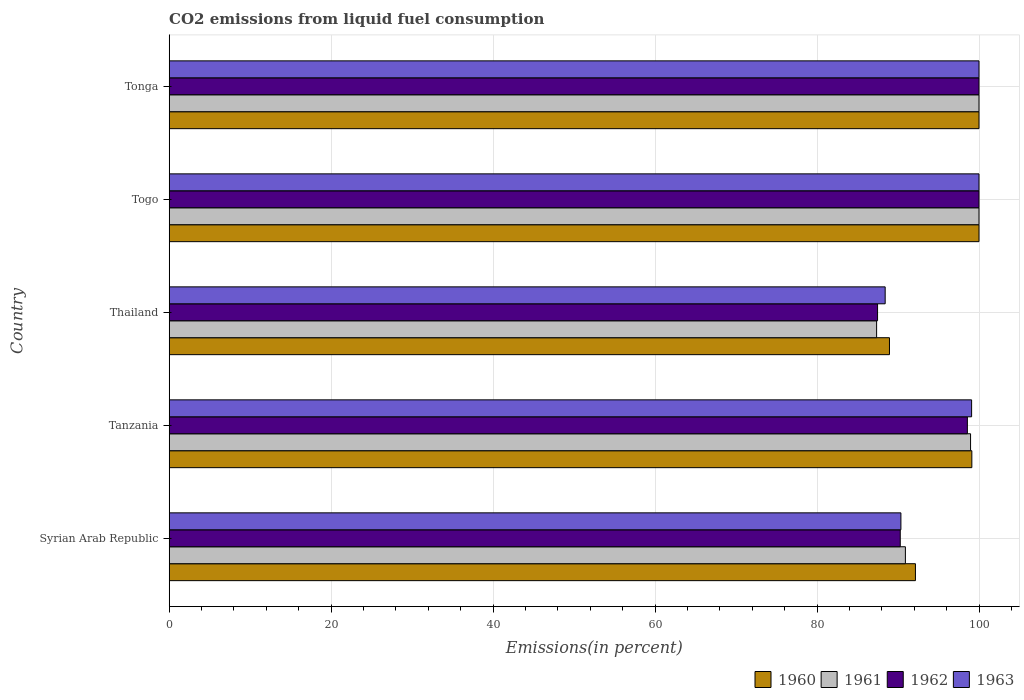What is the label of the 3rd group of bars from the top?
Provide a succinct answer. Thailand. What is the total CO2 emitted in 1963 in Syrian Arab Republic?
Keep it short and to the point. 90.36. Across all countries, what is the minimum total CO2 emitted in 1962?
Make the answer very short. 87.47. In which country was the total CO2 emitted in 1960 maximum?
Your response must be concise. Togo. In which country was the total CO2 emitted in 1962 minimum?
Give a very brief answer. Thailand. What is the total total CO2 emitted in 1963 in the graph?
Your answer should be very brief. 477.86. What is the difference between the total CO2 emitted in 1960 in Thailand and that in Tonga?
Make the answer very short. -11.06. What is the difference between the total CO2 emitted in 1960 in Tanzania and the total CO2 emitted in 1961 in Tonga?
Provide a short and direct response. -0.88. What is the average total CO2 emitted in 1960 per country?
Your answer should be compact. 96.04. What is the difference between the total CO2 emitted in 1961 and total CO2 emitted in 1963 in Togo?
Offer a very short reply. 0. In how many countries, is the total CO2 emitted in 1960 greater than 60 %?
Ensure brevity in your answer.  5. What is the ratio of the total CO2 emitted in 1963 in Syrian Arab Republic to that in Togo?
Provide a succinct answer. 0.9. What is the difference between the highest and the lowest total CO2 emitted in 1961?
Make the answer very short. 12.64. Is the sum of the total CO2 emitted in 1961 in Thailand and Togo greater than the maximum total CO2 emitted in 1962 across all countries?
Your answer should be very brief. Yes. Is it the case that in every country, the sum of the total CO2 emitted in 1961 and total CO2 emitted in 1963 is greater than the sum of total CO2 emitted in 1960 and total CO2 emitted in 1962?
Make the answer very short. No. What does the 3rd bar from the bottom in Tanzania represents?
Give a very brief answer. 1962. Is it the case that in every country, the sum of the total CO2 emitted in 1963 and total CO2 emitted in 1961 is greater than the total CO2 emitted in 1962?
Ensure brevity in your answer.  Yes. How many countries are there in the graph?
Ensure brevity in your answer.  5. What is the difference between two consecutive major ticks on the X-axis?
Provide a short and direct response. 20. Does the graph contain grids?
Keep it short and to the point. Yes. How many legend labels are there?
Your answer should be very brief. 4. How are the legend labels stacked?
Make the answer very short. Horizontal. What is the title of the graph?
Your answer should be compact. CO2 emissions from liquid fuel consumption. What is the label or title of the X-axis?
Your response must be concise. Emissions(in percent). What is the Emissions(in percent) in 1960 in Syrian Arab Republic?
Provide a succinct answer. 92.15. What is the Emissions(in percent) of 1961 in Syrian Arab Republic?
Your answer should be compact. 90.91. What is the Emissions(in percent) of 1962 in Syrian Arab Republic?
Keep it short and to the point. 90.27. What is the Emissions(in percent) in 1963 in Syrian Arab Republic?
Your answer should be very brief. 90.36. What is the Emissions(in percent) in 1960 in Tanzania?
Provide a short and direct response. 99.12. What is the Emissions(in percent) of 1961 in Tanzania?
Your answer should be compact. 98.96. What is the Emissions(in percent) in 1962 in Tanzania?
Your answer should be very brief. 98.56. What is the Emissions(in percent) of 1963 in Tanzania?
Provide a succinct answer. 99.09. What is the Emissions(in percent) of 1960 in Thailand?
Your answer should be compact. 88.94. What is the Emissions(in percent) in 1961 in Thailand?
Ensure brevity in your answer.  87.36. What is the Emissions(in percent) in 1962 in Thailand?
Give a very brief answer. 87.47. What is the Emissions(in percent) of 1963 in Thailand?
Your answer should be very brief. 88.41. What is the Emissions(in percent) in 1960 in Togo?
Your response must be concise. 100. What is the Emissions(in percent) in 1961 in Togo?
Your answer should be very brief. 100. What is the Emissions(in percent) in 1962 in Togo?
Your answer should be compact. 100. What is the Emissions(in percent) of 1962 in Tonga?
Offer a terse response. 100. What is the Emissions(in percent) in 1963 in Tonga?
Give a very brief answer. 100. Across all countries, what is the maximum Emissions(in percent) in 1961?
Offer a very short reply. 100. Across all countries, what is the minimum Emissions(in percent) in 1960?
Provide a short and direct response. 88.94. Across all countries, what is the minimum Emissions(in percent) of 1961?
Give a very brief answer. 87.36. Across all countries, what is the minimum Emissions(in percent) of 1962?
Make the answer very short. 87.47. Across all countries, what is the minimum Emissions(in percent) of 1963?
Provide a short and direct response. 88.41. What is the total Emissions(in percent) of 1960 in the graph?
Your response must be concise. 480.21. What is the total Emissions(in percent) of 1961 in the graph?
Offer a very short reply. 477.22. What is the total Emissions(in percent) in 1962 in the graph?
Offer a very short reply. 476.31. What is the total Emissions(in percent) of 1963 in the graph?
Offer a terse response. 477.86. What is the difference between the Emissions(in percent) of 1960 in Syrian Arab Republic and that in Tanzania?
Make the answer very short. -6.96. What is the difference between the Emissions(in percent) of 1961 in Syrian Arab Republic and that in Tanzania?
Your answer should be compact. -8.05. What is the difference between the Emissions(in percent) in 1962 in Syrian Arab Republic and that in Tanzania?
Provide a short and direct response. -8.29. What is the difference between the Emissions(in percent) in 1963 in Syrian Arab Republic and that in Tanzania?
Keep it short and to the point. -8.73. What is the difference between the Emissions(in percent) in 1960 in Syrian Arab Republic and that in Thailand?
Keep it short and to the point. 3.21. What is the difference between the Emissions(in percent) in 1961 in Syrian Arab Republic and that in Thailand?
Give a very brief answer. 3.55. What is the difference between the Emissions(in percent) in 1962 in Syrian Arab Republic and that in Thailand?
Offer a terse response. 2.8. What is the difference between the Emissions(in percent) of 1963 in Syrian Arab Republic and that in Thailand?
Your answer should be compact. 1.94. What is the difference between the Emissions(in percent) of 1960 in Syrian Arab Republic and that in Togo?
Keep it short and to the point. -7.85. What is the difference between the Emissions(in percent) in 1961 in Syrian Arab Republic and that in Togo?
Your answer should be compact. -9.09. What is the difference between the Emissions(in percent) in 1962 in Syrian Arab Republic and that in Togo?
Your answer should be very brief. -9.73. What is the difference between the Emissions(in percent) of 1963 in Syrian Arab Republic and that in Togo?
Provide a succinct answer. -9.64. What is the difference between the Emissions(in percent) of 1960 in Syrian Arab Republic and that in Tonga?
Keep it short and to the point. -7.85. What is the difference between the Emissions(in percent) in 1961 in Syrian Arab Republic and that in Tonga?
Your answer should be very brief. -9.09. What is the difference between the Emissions(in percent) of 1962 in Syrian Arab Republic and that in Tonga?
Your answer should be very brief. -9.73. What is the difference between the Emissions(in percent) of 1963 in Syrian Arab Republic and that in Tonga?
Your answer should be compact. -9.64. What is the difference between the Emissions(in percent) in 1960 in Tanzania and that in Thailand?
Offer a very short reply. 10.17. What is the difference between the Emissions(in percent) in 1961 in Tanzania and that in Thailand?
Give a very brief answer. 11.6. What is the difference between the Emissions(in percent) of 1962 in Tanzania and that in Thailand?
Provide a short and direct response. 11.09. What is the difference between the Emissions(in percent) in 1963 in Tanzania and that in Thailand?
Offer a terse response. 10.67. What is the difference between the Emissions(in percent) in 1960 in Tanzania and that in Togo?
Ensure brevity in your answer.  -0.89. What is the difference between the Emissions(in percent) in 1961 in Tanzania and that in Togo?
Provide a short and direct response. -1.04. What is the difference between the Emissions(in percent) in 1962 in Tanzania and that in Togo?
Provide a short and direct response. -1.44. What is the difference between the Emissions(in percent) in 1963 in Tanzania and that in Togo?
Offer a very short reply. -0.91. What is the difference between the Emissions(in percent) in 1960 in Tanzania and that in Tonga?
Give a very brief answer. -0.89. What is the difference between the Emissions(in percent) of 1961 in Tanzania and that in Tonga?
Your answer should be very brief. -1.04. What is the difference between the Emissions(in percent) of 1962 in Tanzania and that in Tonga?
Offer a terse response. -1.44. What is the difference between the Emissions(in percent) of 1963 in Tanzania and that in Tonga?
Provide a succinct answer. -0.91. What is the difference between the Emissions(in percent) of 1960 in Thailand and that in Togo?
Offer a terse response. -11.06. What is the difference between the Emissions(in percent) in 1961 in Thailand and that in Togo?
Give a very brief answer. -12.64. What is the difference between the Emissions(in percent) in 1962 in Thailand and that in Togo?
Provide a short and direct response. -12.53. What is the difference between the Emissions(in percent) of 1963 in Thailand and that in Togo?
Your response must be concise. -11.59. What is the difference between the Emissions(in percent) of 1960 in Thailand and that in Tonga?
Offer a terse response. -11.06. What is the difference between the Emissions(in percent) in 1961 in Thailand and that in Tonga?
Give a very brief answer. -12.64. What is the difference between the Emissions(in percent) of 1962 in Thailand and that in Tonga?
Give a very brief answer. -12.53. What is the difference between the Emissions(in percent) in 1963 in Thailand and that in Tonga?
Ensure brevity in your answer.  -11.59. What is the difference between the Emissions(in percent) of 1960 in Togo and that in Tonga?
Keep it short and to the point. 0. What is the difference between the Emissions(in percent) of 1961 in Togo and that in Tonga?
Offer a very short reply. 0. What is the difference between the Emissions(in percent) in 1963 in Togo and that in Tonga?
Your answer should be very brief. 0. What is the difference between the Emissions(in percent) in 1960 in Syrian Arab Republic and the Emissions(in percent) in 1961 in Tanzania?
Offer a very short reply. -6.81. What is the difference between the Emissions(in percent) in 1960 in Syrian Arab Republic and the Emissions(in percent) in 1962 in Tanzania?
Provide a succinct answer. -6.41. What is the difference between the Emissions(in percent) in 1960 in Syrian Arab Republic and the Emissions(in percent) in 1963 in Tanzania?
Offer a very short reply. -6.94. What is the difference between the Emissions(in percent) in 1961 in Syrian Arab Republic and the Emissions(in percent) in 1962 in Tanzania?
Offer a very short reply. -7.66. What is the difference between the Emissions(in percent) in 1961 in Syrian Arab Republic and the Emissions(in percent) in 1963 in Tanzania?
Make the answer very short. -8.18. What is the difference between the Emissions(in percent) in 1962 in Syrian Arab Republic and the Emissions(in percent) in 1963 in Tanzania?
Your answer should be compact. -8.81. What is the difference between the Emissions(in percent) of 1960 in Syrian Arab Republic and the Emissions(in percent) of 1961 in Thailand?
Your answer should be very brief. 4.79. What is the difference between the Emissions(in percent) of 1960 in Syrian Arab Republic and the Emissions(in percent) of 1962 in Thailand?
Ensure brevity in your answer.  4.68. What is the difference between the Emissions(in percent) of 1960 in Syrian Arab Republic and the Emissions(in percent) of 1963 in Thailand?
Give a very brief answer. 3.74. What is the difference between the Emissions(in percent) of 1961 in Syrian Arab Republic and the Emissions(in percent) of 1962 in Thailand?
Provide a succinct answer. 3.44. What is the difference between the Emissions(in percent) in 1961 in Syrian Arab Republic and the Emissions(in percent) in 1963 in Thailand?
Your answer should be compact. 2.5. What is the difference between the Emissions(in percent) of 1962 in Syrian Arab Republic and the Emissions(in percent) of 1963 in Thailand?
Offer a terse response. 1.86. What is the difference between the Emissions(in percent) in 1960 in Syrian Arab Republic and the Emissions(in percent) in 1961 in Togo?
Your answer should be compact. -7.85. What is the difference between the Emissions(in percent) in 1960 in Syrian Arab Republic and the Emissions(in percent) in 1962 in Togo?
Ensure brevity in your answer.  -7.85. What is the difference between the Emissions(in percent) in 1960 in Syrian Arab Republic and the Emissions(in percent) in 1963 in Togo?
Your response must be concise. -7.85. What is the difference between the Emissions(in percent) of 1961 in Syrian Arab Republic and the Emissions(in percent) of 1962 in Togo?
Provide a short and direct response. -9.09. What is the difference between the Emissions(in percent) of 1961 in Syrian Arab Republic and the Emissions(in percent) of 1963 in Togo?
Your answer should be very brief. -9.09. What is the difference between the Emissions(in percent) in 1962 in Syrian Arab Republic and the Emissions(in percent) in 1963 in Togo?
Your answer should be very brief. -9.73. What is the difference between the Emissions(in percent) of 1960 in Syrian Arab Republic and the Emissions(in percent) of 1961 in Tonga?
Your answer should be compact. -7.85. What is the difference between the Emissions(in percent) of 1960 in Syrian Arab Republic and the Emissions(in percent) of 1962 in Tonga?
Your answer should be very brief. -7.85. What is the difference between the Emissions(in percent) in 1960 in Syrian Arab Republic and the Emissions(in percent) in 1963 in Tonga?
Your response must be concise. -7.85. What is the difference between the Emissions(in percent) in 1961 in Syrian Arab Republic and the Emissions(in percent) in 1962 in Tonga?
Provide a short and direct response. -9.09. What is the difference between the Emissions(in percent) in 1961 in Syrian Arab Republic and the Emissions(in percent) in 1963 in Tonga?
Provide a short and direct response. -9.09. What is the difference between the Emissions(in percent) in 1962 in Syrian Arab Republic and the Emissions(in percent) in 1963 in Tonga?
Your answer should be compact. -9.73. What is the difference between the Emissions(in percent) in 1960 in Tanzania and the Emissions(in percent) in 1961 in Thailand?
Ensure brevity in your answer.  11.76. What is the difference between the Emissions(in percent) of 1960 in Tanzania and the Emissions(in percent) of 1962 in Thailand?
Your response must be concise. 11.64. What is the difference between the Emissions(in percent) in 1960 in Tanzania and the Emissions(in percent) in 1963 in Thailand?
Keep it short and to the point. 10.7. What is the difference between the Emissions(in percent) of 1961 in Tanzania and the Emissions(in percent) of 1962 in Thailand?
Keep it short and to the point. 11.49. What is the difference between the Emissions(in percent) of 1961 in Tanzania and the Emissions(in percent) of 1963 in Thailand?
Give a very brief answer. 10.54. What is the difference between the Emissions(in percent) in 1962 in Tanzania and the Emissions(in percent) in 1963 in Thailand?
Your answer should be compact. 10.15. What is the difference between the Emissions(in percent) of 1960 in Tanzania and the Emissions(in percent) of 1961 in Togo?
Provide a short and direct response. -0.89. What is the difference between the Emissions(in percent) of 1960 in Tanzania and the Emissions(in percent) of 1962 in Togo?
Give a very brief answer. -0.89. What is the difference between the Emissions(in percent) in 1960 in Tanzania and the Emissions(in percent) in 1963 in Togo?
Your answer should be compact. -0.89. What is the difference between the Emissions(in percent) in 1961 in Tanzania and the Emissions(in percent) in 1962 in Togo?
Offer a very short reply. -1.04. What is the difference between the Emissions(in percent) in 1961 in Tanzania and the Emissions(in percent) in 1963 in Togo?
Offer a terse response. -1.04. What is the difference between the Emissions(in percent) of 1962 in Tanzania and the Emissions(in percent) of 1963 in Togo?
Make the answer very short. -1.44. What is the difference between the Emissions(in percent) in 1960 in Tanzania and the Emissions(in percent) in 1961 in Tonga?
Ensure brevity in your answer.  -0.89. What is the difference between the Emissions(in percent) of 1960 in Tanzania and the Emissions(in percent) of 1962 in Tonga?
Offer a very short reply. -0.89. What is the difference between the Emissions(in percent) in 1960 in Tanzania and the Emissions(in percent) in 1963 in Tonga?
Provide a short and direct response. -0.89. What is the difference between the Emissions(in percent) in 1961 in Tanzania and the Emissions(in percent) in 1962 in Tonga?
Ensure brevity in your answer.  -1.04. What is the difference between the Emissions(in percent) of 1961 in Tanzania and the Emissions(in percent) of 1963 in Tonga?
Offer a very short reply. -1.04. What is the difference between the Emissions(in percent) in 1962 in Tanzania and the Emissions(in percent) in 1963 in Tonga?
Offer a very short reply. -1.44. What is the difference between the Emissions(in percent) of 1960 in Thailand and the Emissions(in percent) of 1961 in Togo?
Keep it short and to the point. -11.06. What is the difference between the Emissions(in percent) of 1960 in Thailand and the Emissions(in percent) of 1962 in Togo?
Offer a very short reply. -11.06. What is the difference between the Emissions(in percent) of 1960 in Thailand and the Emissions(in percent) of 1963 in Togo?
Your answer should be compact. -11.06. What is the difference between the Emissions(in percent) of 1961 in Thailand and the Emissions(in percent) of 1962 in Togo?
Keep it short and to the point. -12.64. What is the difference between the Emissions(in percent) of 1961 in Thailand and the Emissions(in percent) of 1963 in Togo?
Make the answer very short. -12.64. What is the difference between the Emissions(in percent) of 1962 in Thailand and the Emissions(in percent) of 1963 in Togo?
Keep it short and to the point. -12.53. What is the difference between the Emissions(in percent) in 1960 in Thailand and the Emissions(in percent) in 1961 in Tonga?
Ensure brevity in your answer.  -11.06. What is the difference between the Emissions(in percent) of 1960 in Thailand and the Emissions(in percent) of 1962 in Tonga?
Keep it short and to the point. -11.06. What is the difference between the Emissions(in percent) of 1960 in Thailand and the Emissions(in percent) of 1963 in Tonga?
Give a very brief answer. -11.06. What is the difference between the Emissions(in percent) of 1961 in Thailand and the Emissions(in percent) of 1962 in Tonga?
Make the answer very short. -12.64. What is the difference between the Emissions(in percent) in 1961 in Thailand and the Emissions(in percent) in 1963 in Tonga?
Offer a very short reply. -12.64. What is the difference between the Emissions(in percent) of 1962 in Thailand and the Emissions(in percent) of 1963 in Tonga?
Your response must be concise. -12.53. What is the average Emissions(in percent) of 1960 per country?
Offer a very short reply. 96.04. What is the average Emissions(in percent) in 1961 per country?
Ensure brevity in your answer.  95.44. What is the average Emissions(in percent) in 1962 per country?
Your answer should be compact. 95.26. What is the average Emissions(in percent) of 1963 per country?
Your response must be concise. 95.57. What is the difference between the Emissions(in percent) in 1960 and Emissions(in percent) in 1961 in Syrian Arab Republic?
Offer a very short reply. 1.24. What is the difference between the Emissions(in percent) in 1960 and Emissions(in percent) in 1962 in Syrian Arab Republic?
Ensure brevity in your answer.  1.88. What is the difference between the Emissions(in percent) in 1960 and Emissions(in percent) in 1963 in Syrian Arab Republic?
Offer a terse response. 1.79. What is the difference between the Emissions(in percent) of 1961 and Emissions(in percent) of 1962 in Syrian Arab Republic?
Offer a terse response. 0.63. What is the difference between the Emissions(in percent) of 1961 and Emissions(in percent) of 1963 in Syrian Arab Republic?
Provide a succinct answer. 0.55. What is the difference between the Emissions(in percent) in 1962 and Emissions(in percent) in 1963 in Syrian Arab Republic?
Offer a very short reply. -0.08. What is the difference between the Emissions(in percent) of 1960 and Emissions(in percent) of 1961 in Tanzania?
Offer a very short reply. 0.16. What is the difference between the Emissions(in percent) of 1960 and Emissions(in percent) of 1962 in Tanzania?
Offer a terse response. 0.55. What is the difference between the Emissions(in percent) in 1960 and Emissions(in percent) in 1963 in Tanzania?
Your answer should be compact. 0.03. What is the difference between the Emissions(in percent) of 1961 and Emissions(in percent) of 1962 in Tanzania?
Offer a very short reply. 0.39. What is the difference between the Emissions(in percent) of 1961 and Emissions(in percent) of 1963 in Tanzania?
Offer a very short reply. -0.13. What is the difference between the Emissions(in percent) in 1962 and Emissions(in percent) in 1963 in Tanzania?
Give a very brief answer. -0.52. What is the difference between the Emissions(in percent) of 1960 and Emissions(in percent) of 1961 in Thailand?
Offer a terse response. 1.59. What is the difference between the Emissions(in percent) of 1960 and Emissions(in percent) of 1962 in Thailand?
Your answer should be compact. 1.47. What is the difference between the Emissions(in percent) in 1960 and Emissions(in percent) in 1963 in Thailand?
Give a very brief answer. 0.53. What is the difference between the Emissions(in percent) in 1961 and Emissions(in percent) in 1962 in Thailand?
Give a very brief answer. -0.12. What is the difference between the Emissions(in percent) in 1961 and Emissions(in percent) in 1963 in Thailand?
Keep it short and to the point. -1.06. What is the difference between the Emissions(in percent) of 1962 and Emissions(in percent) of 1963 in Thailand?
Keep it short and to the point. -0.94. What is the difference between the Emissions(in percent) of 1960 and Emissions(in percent) of 1961 in Togo?
Make the answer very short. 0. What is the difference between the Emissions(in percent) in 1960 and Emissions(in percent) in 1963 in Togo?
Your response must be concise. 0. What is the difference between the Emissions(in percent) of 1961 and Emissions(in percent) of 1962 in Togo?
Offer a terse response. 0. What is the difference between the Emissions(in percent) of 1960 and Emissions(in percent) of 1962 in Tonga?
Offer a very short reply. 0. What is the difference between the Emissions(in percent) of 1961 and Emissions(in percent) of 1962 in Tonga?
Your answer should be very brief. 0. What is the difference between the Emissions(in percent) of 1962 and Emissions(in percent) of 1963 in Tonga?
Keep it short and to the point. 0. What is the ratio of the Emissions(in percent) in 1960 in Syrian Arab Republic to that in Tanzania?
Your response must be concise. 0.93. What is the ratio of the Emissions(in percent) in 1961 in Syrian Arab Republic to that in Tanzania?
Your answer should be very brief. 0.92. What is the ratio of the Emissions(in percent) in 1962 in Syrian Arab Republic to that in Tanzania?
Provide a short and direct response. 0.92. What is the ratio of the Emissions(in percent) of 1963 in Syrian Arab Republic to that in Tanzania?
Provide a succinct answer. 0.91. What is the ratio of the Emissions(in percent) in 1960 in Syrian Arab Republic to that in Thailand?
Ensure brevity in your answer.  1.04. What is the ratio of the Emissions(in percent) in 1961 in Syrian Arab Republic to that in Thailand?
Your answer should be compact. 1.04. What is the ratio of the Emissions(in percent) in 1962 in Syrian Arab Republic to that in Thailand?
Provide a short and direct response. 1.03. What is the ratio of the Emissions(in percent) of 1960 in Syrian Arab Republic to that in Togo?
Offer a very short reply. 0.92. What is the ratio of the Emissions(in percent) in 1961 in Syrian Arab Republic to that in Togo?
Keep it short and to the point. 0.91. What is the ratio of the Emissions(in percent) in 1962 in Syrian Arab Republic to that in Togo?
Provide a short and direct response. 0.9. What is the ratio of the Emissions(in percent) of 1963 in Syrian Arab Republic to that in Togo?
Make the answer very short. 0.9. What is the ratio of the Emissions(in percent) in 1960 in Syrian Arab Republic to that in Tonga?
Make the answer very short. 0.92. What is the ratio of the Emissions(in percent) of 1962 in Syrian Arab Republic to that in Tonga?
Give a very brief answer. 0.9. What is the ratio of the Emissions(in percent) in 1963 in Syrian Arab Republic to that in Tonga?
Your response must be concise. 0.9. What is the ratio of the Emissions(in percent) of 1960 in Tanzania to that in Thailand?
Offer a terse response. 1.11. What is the ratio of the Emissions(in percent) of 1961 in Tanzania to that in Thailand?
Your response must be concise. 1.13. What is the ratio of the Emissions(in percent) of 1962 in Tanzania to that in Thailand?
Make the answer very short. 1.13. What is the ratio of the Emissions(in percent) in 1963 in Tanzania to that in Thailand?
Your answer should be compact. 1.12. What is the ratio of the Emissions(in percent) in 1960 in Tanzania to that in Togo?
Ensure brevity in your answer.  0.99. What is the ratio of the Emissions(in percent) in 1962 in Tanzania to that in Togo?
Give a very brief answer. 0.99. What is the ratio of the Emissions(in percent) in 1963 in Tanzania to that in Togo?
Give a very brief answer. 0.99. What is the ratio of the Emissions(in percent) in 1961 in Tanzania to that in Tonga?
Your answer should be very brief. 0.99. What is the ratio of the Emissions(in percent) of 1962 in Tanzania to that in Tonga?
Give a very brief answer. 0.99. What is the ratio of the Emissions(in percent) of 1963 in Tanzania to that in Tonga?
Keep it short and to the point. 0.99. What is the ratio of the Emissions(in percent) in 1960 in Thailand to that in Togo?
Your response must be concise. 0.89. What is the ratio of the Emissions(in percent) in 1961 in Thailand to that in Togo?
Give a very brief answer. 0.87. What is the ratio of the Emissions(in percent) in 1962 in Thailand to that in Togo?
Your response must be concise. 0.87. What is the ratio of the Emissions(in percent) in 1963 in Thailand to that in Togo?
Keep it short and to the point. 0.88. What is the ratio of the Emissions(in percent) in 1960 in Thailand to that in Tonga?
Your answer should be very brief. 0.89. What is the ratio of the Emissions(in percent) of 1961 in Thailand to that in Tonga?
Your answer should be compact. 0.87. What is the ratio of the Emissions(in percent) in 1962 in Thailand to that in Tonga?
Your response must be concise. 0.87. What is the ratio of the Emissions(in percent) of 1963 in Thailand to that in Tonga?
Your answer should be very brief. 0.88. What is the ratio of the Emissions(in percent) of 1961 in Togo to that in Tonga?
Your answer should be very brief. 1. What is the ratio of the Emissions(in percent) in 1963 in Togo to that in Tonga?
Your answer should be compact. 1. What is the difference between the highest and the second highest Emissions(in percent) of 1960?
Your answer should be very brief. 0. What is the difference between the highest and the second highest Emissions(in percent) in 1962?
Ensure brevity in your answer.  0. What is the difference between the highest and the lowest Emissions(in percent) of 1960?
Your answer should be compact. 11.06. What is the difference between the highest and the lowest Emissions(in percent) of 1961?
Keep it short and to the point. 12.64. What is the difference between the highest and the lowest Emissions(in percent) of 1962?
Offer a terse response. 12.53. What is the difference between the highest and the lowest Emissions(in percent) of 1963?
Your response must be concise. 11.59. 